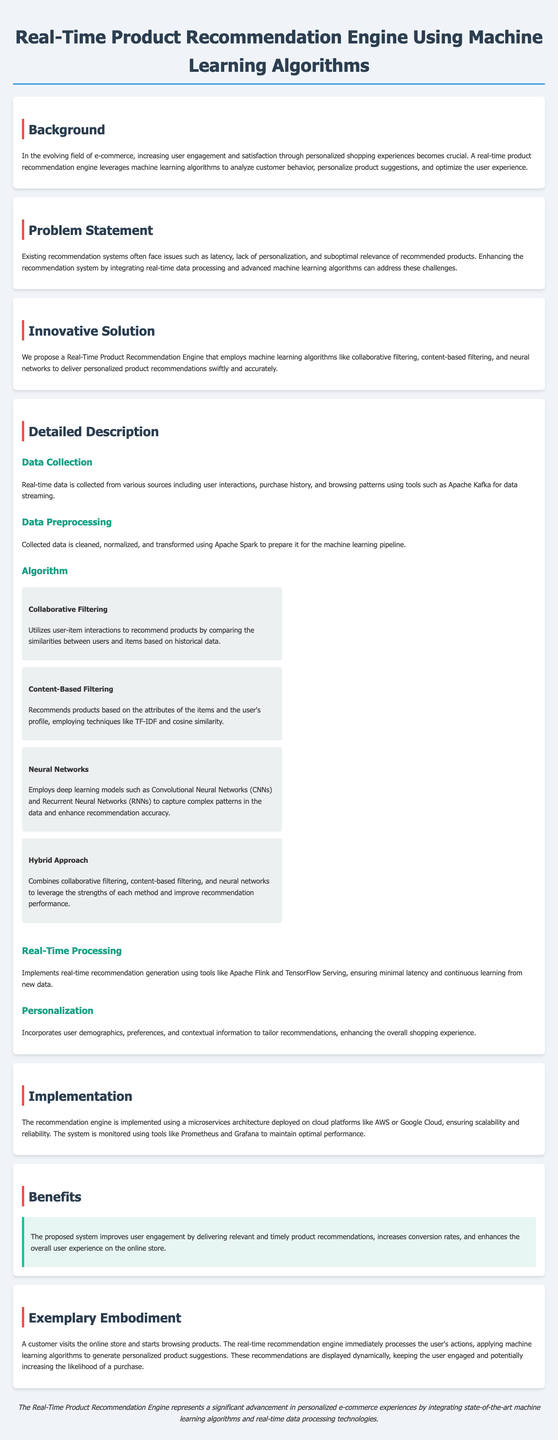What is the main purpose of the recommendation engine? The purpose of the recommendation engine is to analyze customer behavior, personalize product suggestions, and optimize user experience.
Answer: Optimize user experience What algorithms are utilized in the engine? The document lists the algorithms employed in the recommendation engine including collaborative filtering, content-based filtering, and neural networks.
Answer: Collaborative filtering, content-based filtering, neural networks What tool is mentioned for data streaming? The document specifies a tool used for collecting real-time data from various sources.
Answer: Apache Kafka What is the benefit of the proposed system? The document describes an improvement in user engagement as one of the main benefits of the recommendation engine.
Answer: Improves user engagement What type of architecture is the recommendation engine implemented with? The implementation of the recommendation engine is based on a specific architecture that supports scalability and reliability.
Answer: Microservices architecture Which machine learning model is suggested for capturing complex patterns? The document states that a specific type of neural network can be used to enhance recommendation accuracy by capturing complex patterns.
Answer: Convolutional Neural Networks What system is used for monitoring performance? The performance of the recommendation engine is maintained using a specified monitoring tool mentioned in the document.
Answer: Prometheus What is the primary data source used for real-time recommendations? The primary data source of the recommendation engine involves tracking customer interactions and behaviors.
Answer: User interactions 